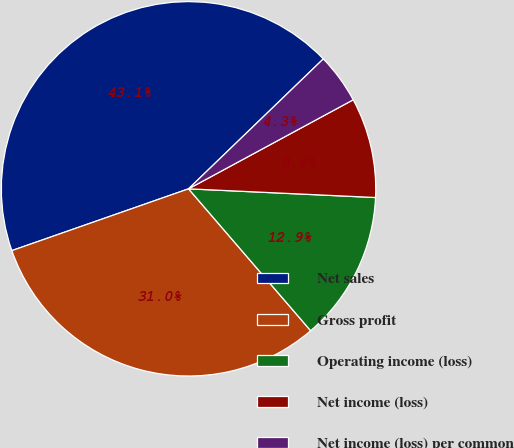Convert chart. <chart><loc_0><loc_0><loc_500><loc_500><pie_chart><fcel>Net sales<fcel>Gross profit<fcel>Operating income (loss)<fcel>Net income (loss)<fcel>Net income (loss) per common<nl><fcel>43.15%<fcel>30.96%<fcel>12.95%<fcel>8.63%<fcel>4.32%<nl></chart> 